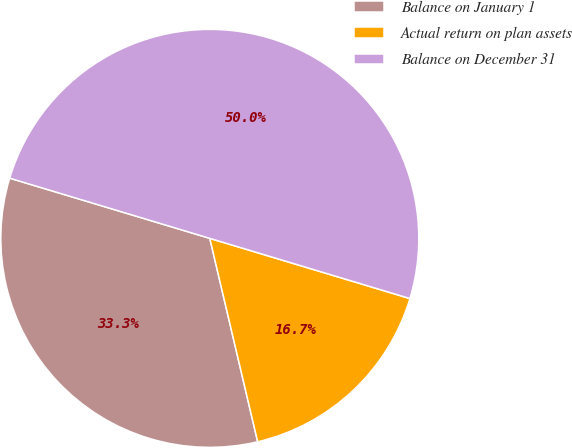<chart> <loc_0><loc_0><loc_500><loc_500><pie_chart><fcel>Balance on January 1<fcel>Actual return on plan assets<fcel>Balance on December 31<nl><fcel>33.33%<fcel>16.67%<fcel>50.0%<nl></chart> 